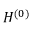Convert formula to latex. <formula><loc_0><loc_0><loc_500><loc_500>H ^ { ( 0 ) }</formula> 